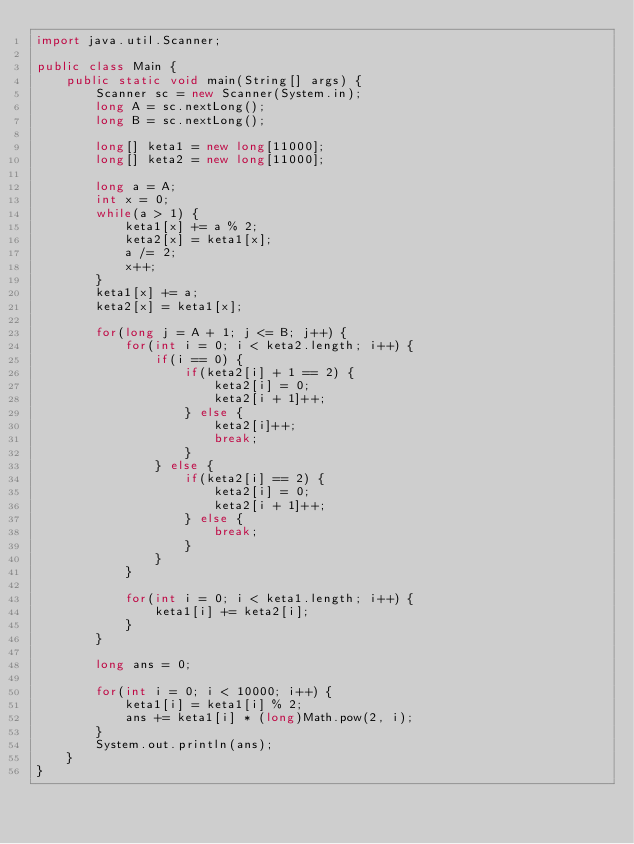Convert code to text. <code><loc_0><loc_0><loc_500><loc_500><_Java_>import java.util.Scanner;

public class Main {
	public static void main(String[] args) {
		Scanner sc = new Scanner(System.in);
		long A = sc.nextLong();
		long B = sc.nextLong();
		
		long[] keta1 = new long[11000];
		long[] keta2 = new long[11000];
		
		long a = A;
		int x = 0;	
		while(a > 1) {
			keta1[x] += a % 2;
			keta2[x] = keta1[x];
			a /= 2;
			x++;
		} 
		keta1[x] += a;
		keta2[x] = keta1[x];
		
		for(long j = A + 1; j <= B; j++) {
			for(int i = 0; i < keta2.length; i++) {
				if(i == 0) {
					if(keta2[i] + 1 == 2) {
						keta2[i] = 0;
						keta2[i + 1]++;
					} else {
						keta2[i]++;
						break;
					}
				} else {
					if(keta2[i] == 2) {
						keta2[i] = 0;
						keta2[i + 1]++;
					} else {
						break;
					}
				}
			}
			
			for(int i = 0; i < keta1.length; i++) {
				keta1[i] += keta2[i];
			}
		}
		
		long ans = 0;
		
		for(int i = 0; i < 10000; i++) {
			keta1[i] = keta1[i] % 2;
			ans += keta1[i] * (long)Math.pow(2, i);
		}
		System.out.println(ans);
	}
}
</code> 